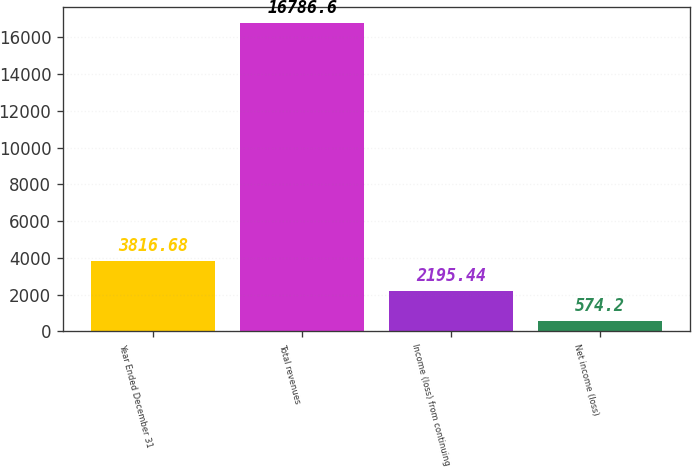Convert chart to OTSL. <chart><loc_0><loc_0><loc_500><loc_500><bar_chart><fcel>Year Ended December 31<fcel>Total revenues<fcel>Income (loss) from continuing<fcel>Net income (loss)<nl><fcel>3816.68<fcel>16786.6<fcel>2195.44<fcel>574.2<nl></chart> 